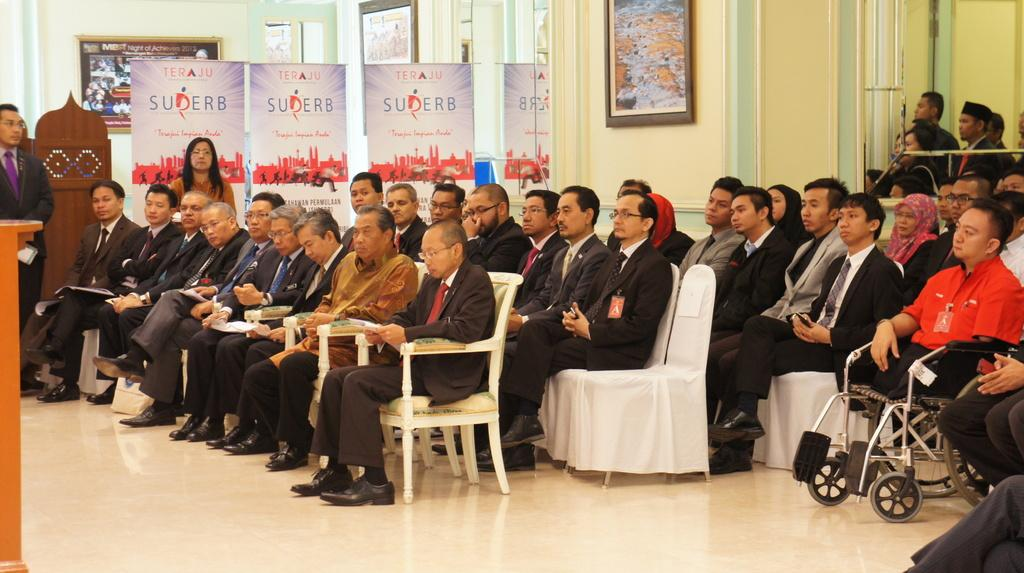How many people are in the image? There is a group of people in the image, but the exact number is not specified. What are some of the people in the image doing? Some people are sitting on chairs, while others are standing. What can be seen hanging in the image? There are banners in the image. What type of structure is visible in the image? There is a wall in the image. What objects are present in the image that might be used for displaying items? There are frames in the image. What is the purpose of the podium in the image? The podium in the image might be used for speeches or presentations. What type of ray is visible in the image? There is no ray present in the image. What type of insurance policy is being discussed at the event in the image? There is no indication of any insurance-related discussion in the image. 